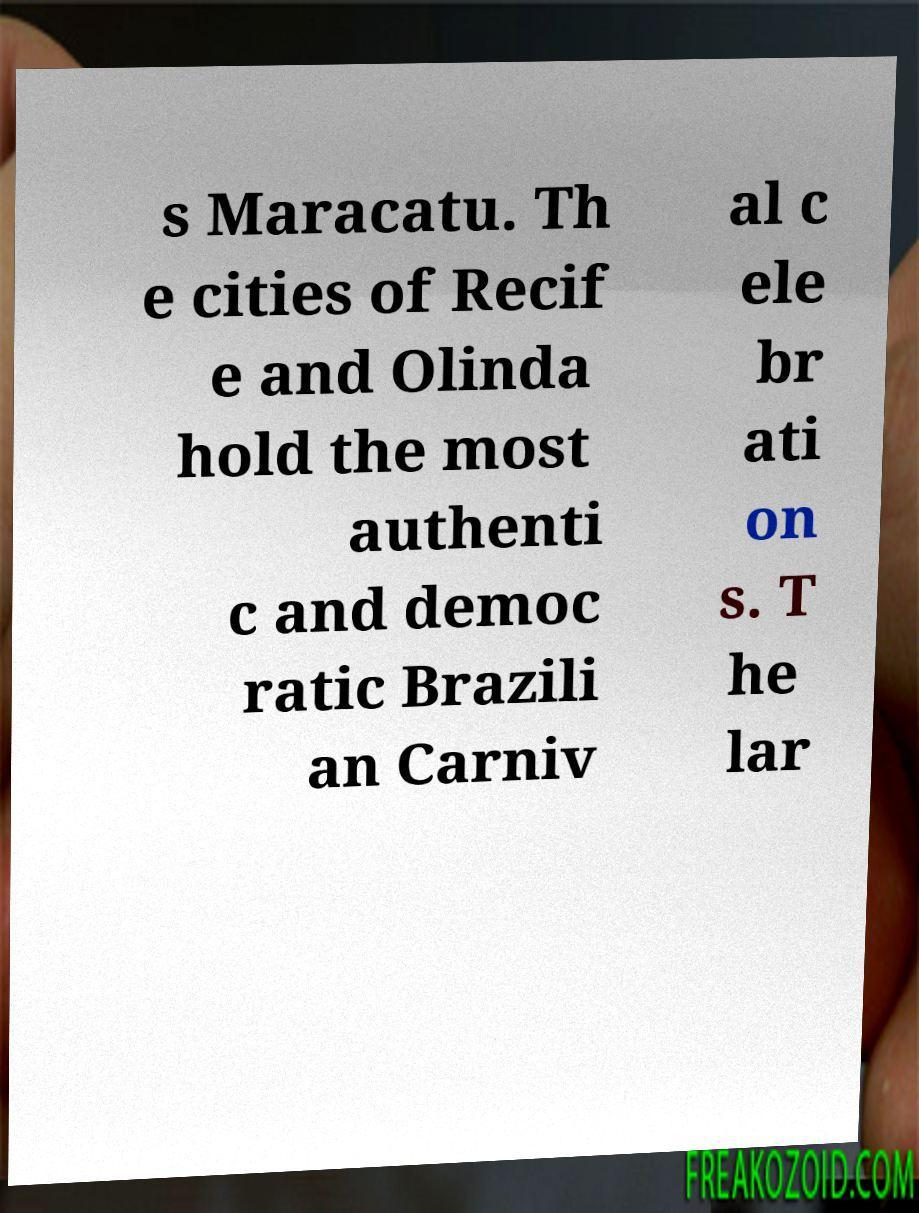What messages or text are displayed in this image? I need them in a readable, typed format. s Maracatu. Th e cities of Recif e and Olinda hold the most authenti c and democ ratic Brazili an Carniv al c ele br ati on s. T he lar 